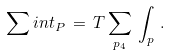Convert formula to latex. <formula><loc_0><loc_0><loc_500><loc_500>\sum i n t _ { P } \, = \, T \sum _ { p _ { 4 } } \, \int _ { p } \, .</formula> 